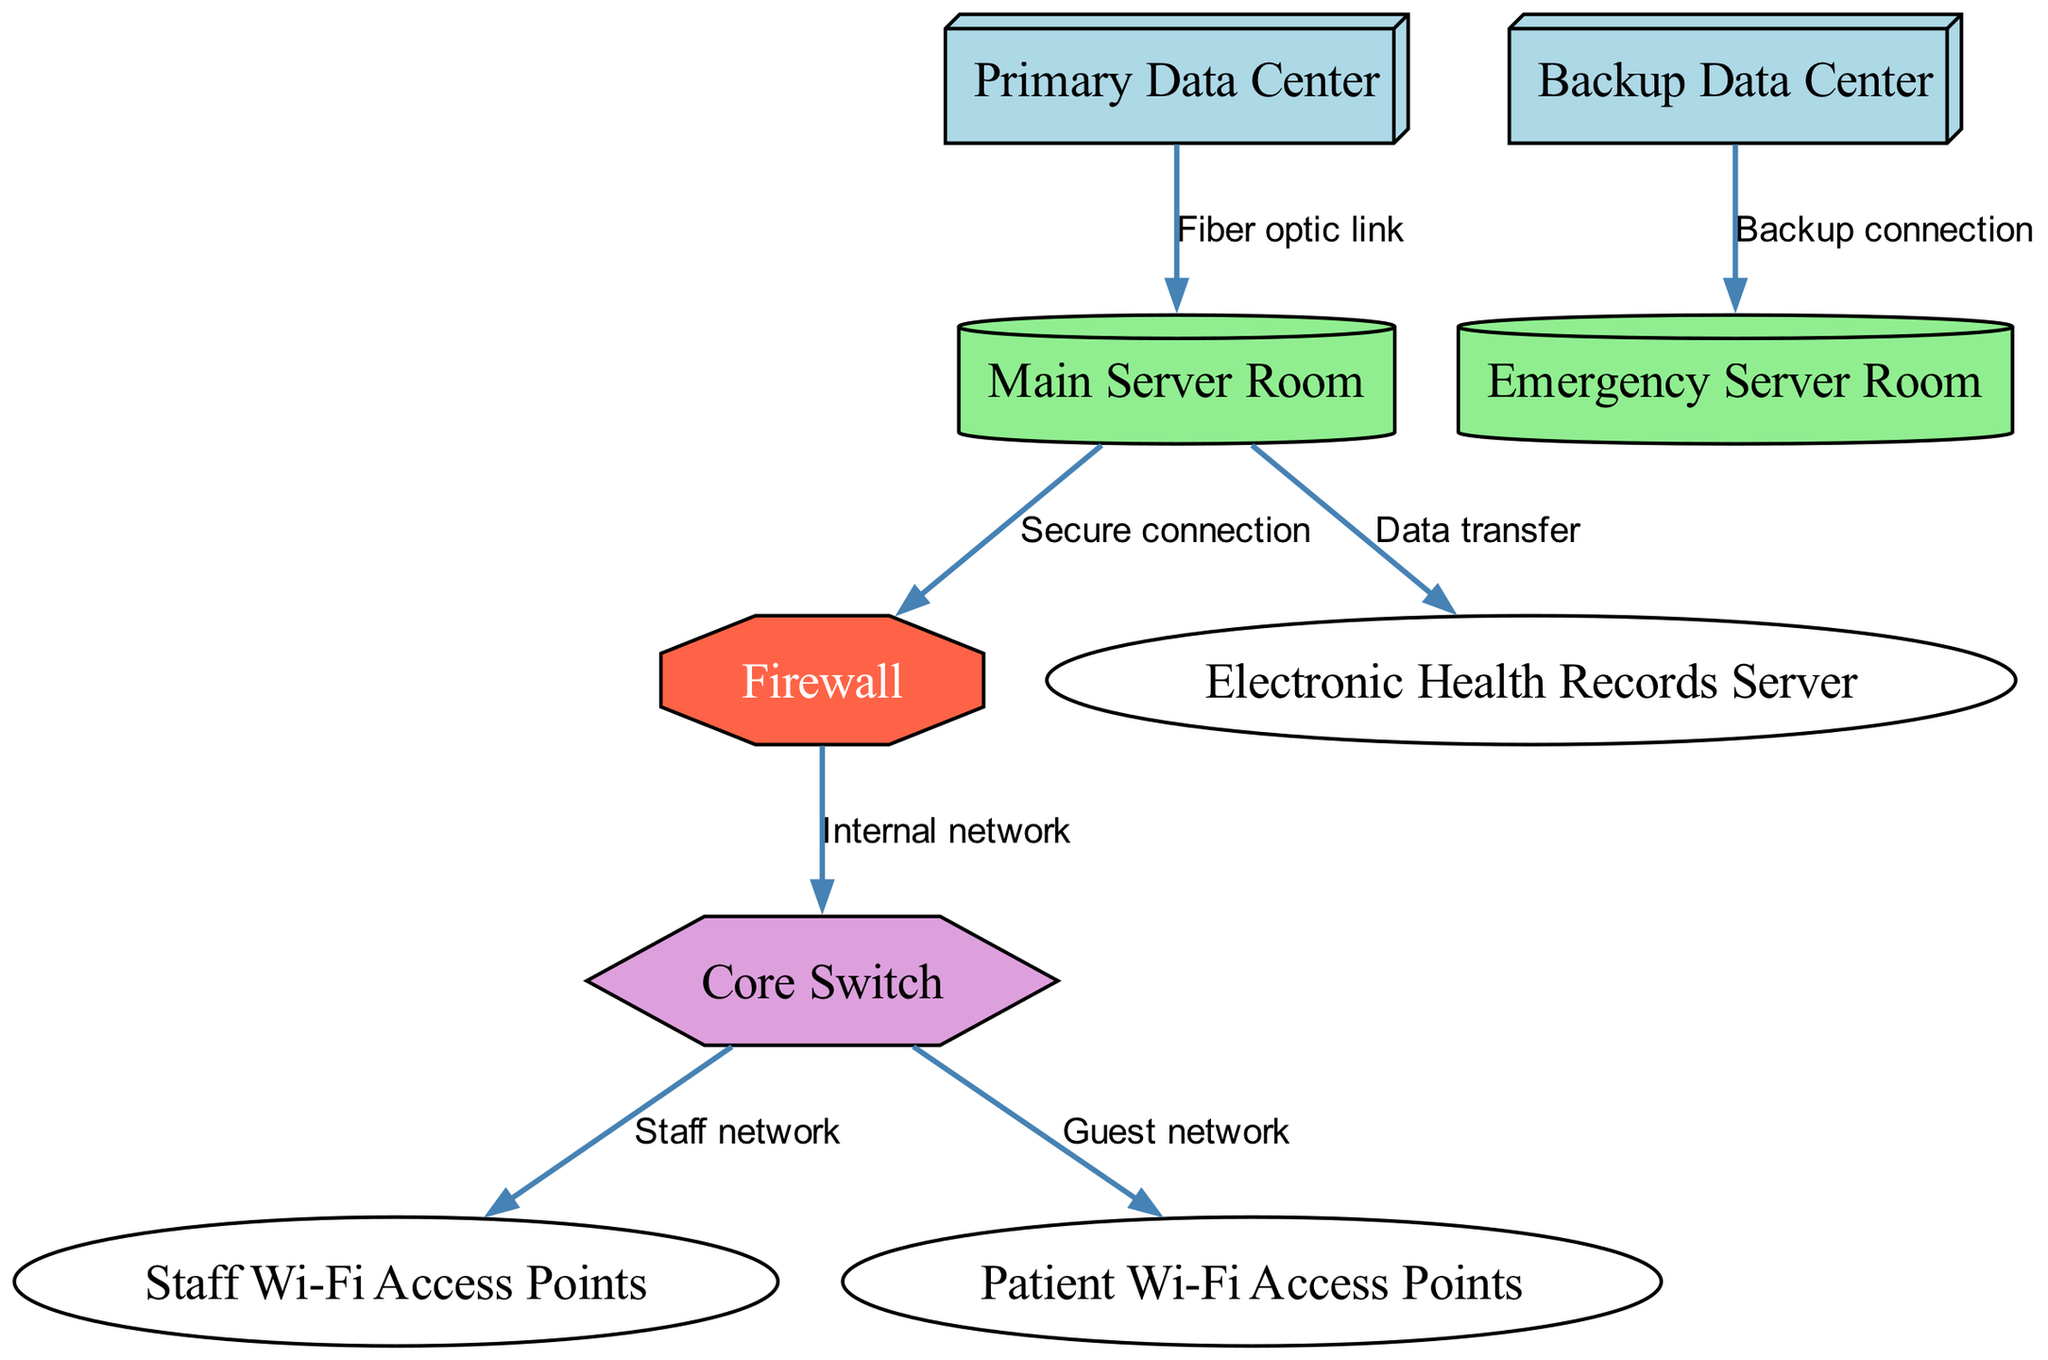What are the two data centers shown in the diagram? The nodes labeled as "Primary Data Center" and "Backup Data Center" represent the two data centers.
Answer: Primary Data Center, Backup Data Center How many server rooms are depicted in the diagram? The diagram shows two server rooms, identifiable by the labels "Main Server Room" and "Emergency Server Room."
Answer: 2 What type of connection links the Primary Data Center to the Main Server Room? The connection between these nodes is labelled "Fiber optic link," which indicates the type of connection used.
Answer: Fiber optic link Which server is connected to the Main Server Room? The "Electronic Health Records Server" is connected to the Main Server Room as indicated by the edge labeled "Data transfer."
Answer: Electronic Health Records Server What component serves as a barrier to the internal network? The "Firewall" serves as a security barrier between the Main Server Room and the Core Switch, as indicated by the edge labeled "Secure connection."
Answer: Firewall What kind of network do the Staff Wi-Fi Access Points belong to? The Staff Wi-Fi Access Points are connected to the Core Switch via an edge labeled "Staff network," which designates the type of network.
Answer: Staff network How many connections are made from the Core Switch? The Core Switch has two edges leading from it, indicating it connects to both the Staff Wi-Fi Access Points and the Patient Wi-Fi Access Points.
Answer: 2 What is the shape used to represent server rooms in the diagram? The "cylinder" shape is used to represent both server rooms in the diagram, as inferred from the custom node styles section.
Answer: Cylinder What does the edge labeled "Backup connection" indicate? This edge represents the connection between the Backup Data Center and the Emergency Server Room, denoting a secondary line of support.
Answer: Backup connection 